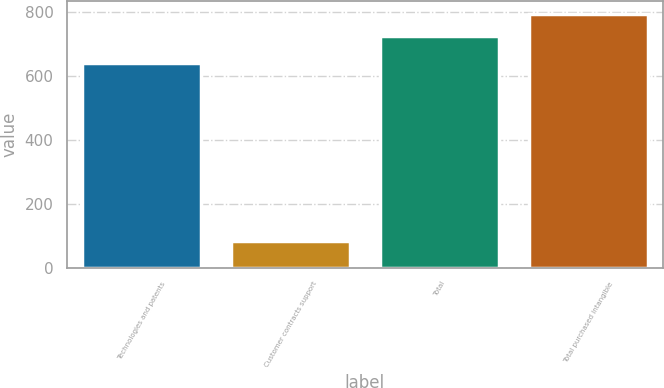Convert chart. <chart><loc_0><loc_0><loc_500><loc_500><bar_chart><fcel>Technologies and patents<fcel>Customer contracts support<fcel>Total<fcel>Total purchased intangible<nl><fcel>640.3<fcel>83.6<fcel>725.9<fcel>795.03<nl></chart> 